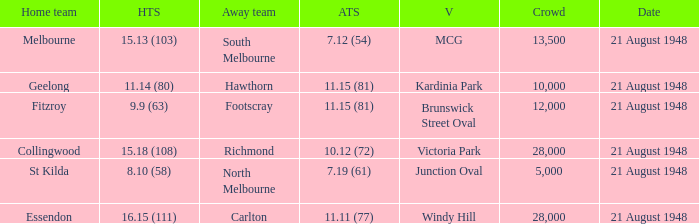If the Away team is north melbourne, what's the Home team score? 8.10 (58). 